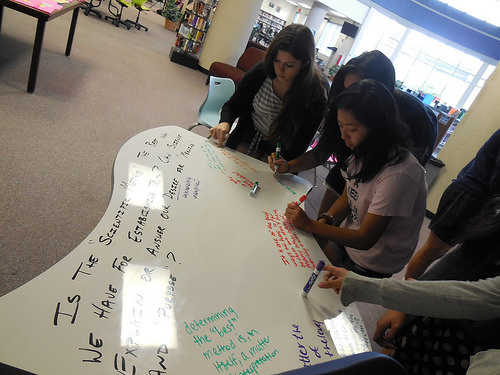<image>
Can you confirm if the woman is behind the table? Yes. From this viewpoint, the woman is positioned behind the table, with the table partially or fully occluding the woman. 